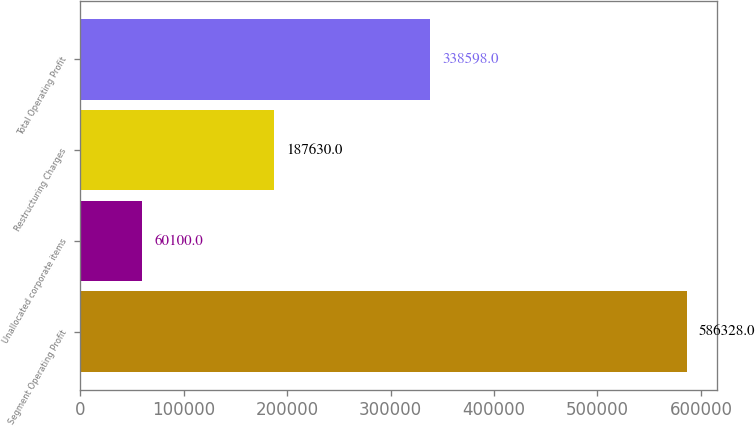Convert chart. <chart><loc_0><loc_0><loc_500><loc_500><bar_chart><fcel>Segment Operating Profit<fcel>Unallocated corporate items<fcel>Restructuring Charges<fcel>Total Operating Profit<nl><fcel>586328<fcel>60100<fcel>187630<fcel>338598<nl></chart> 